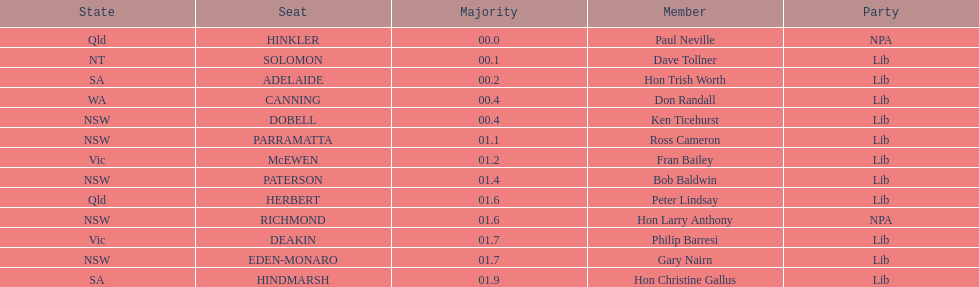How many members in total? 13. 